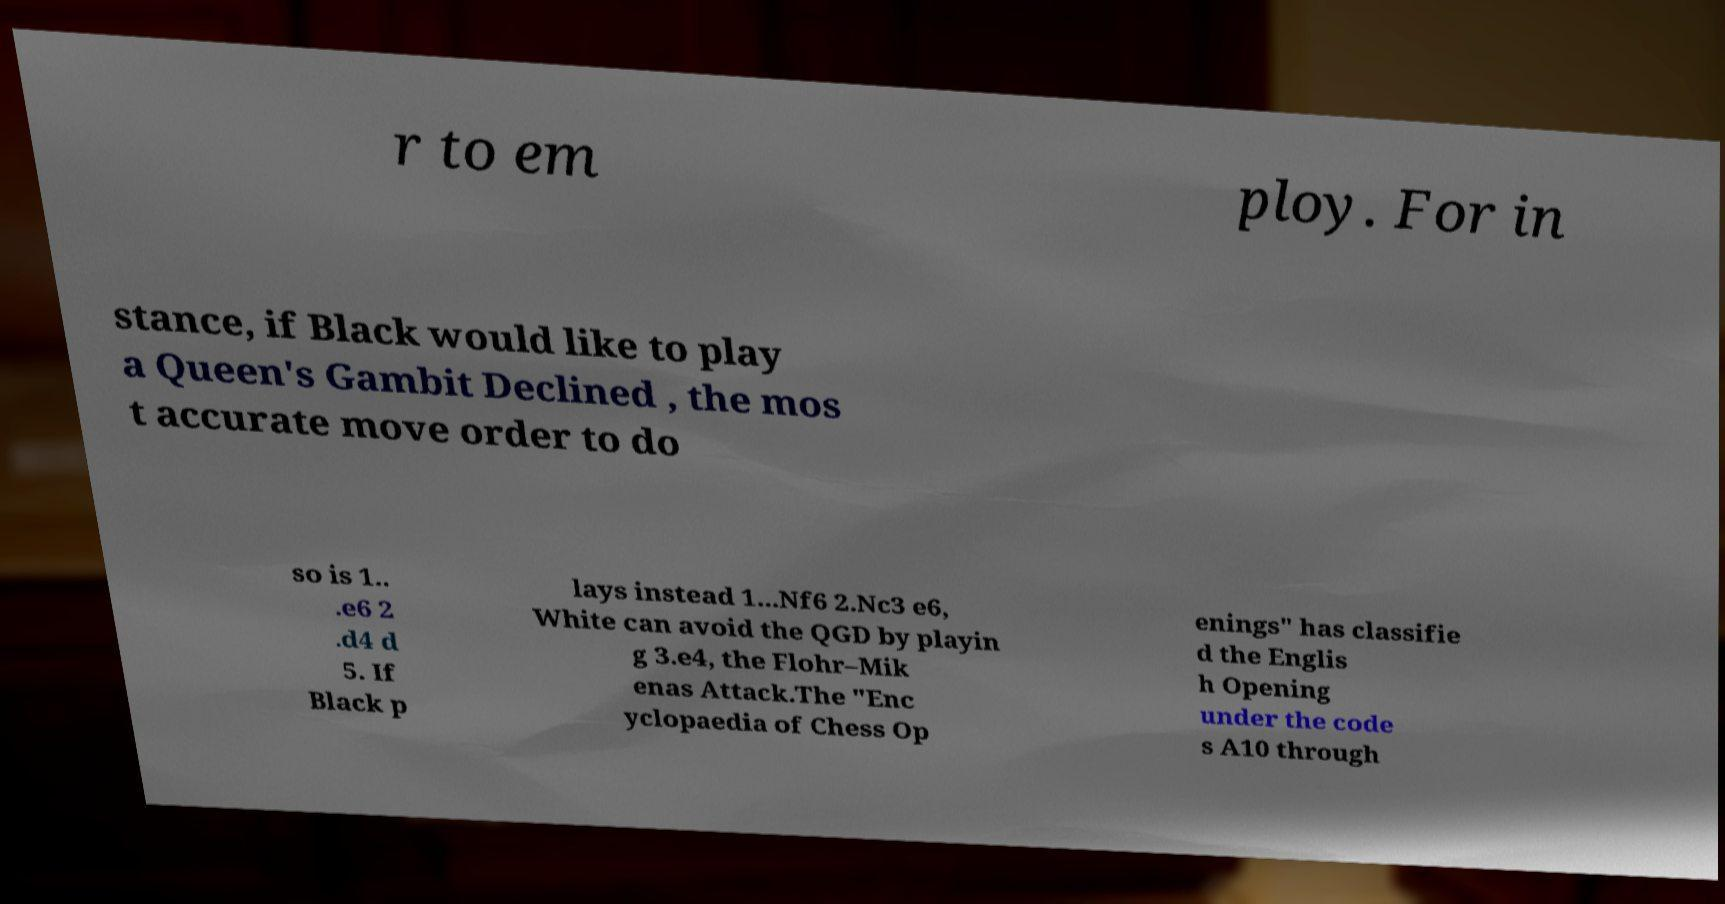Can you read and provide the text displayed in the image?This photo seems to have some interesting text. Can you extract and type it out for me? r to em ploy. For in stance, if Black would like to play a Queen's Gambit Declined , the mos t accurate move order to do so is 1.. .e6 2 .d4 d 5. If Black p lays instead 1...Nf6 2.Nc3 e6, White can avoid the QGD by playin g 3.e4, the Flohr–Mik enas Attack.The "Enc yclopaedia of Chess Op enings" has classifie d the Englis h Opening under the code s A10 through 